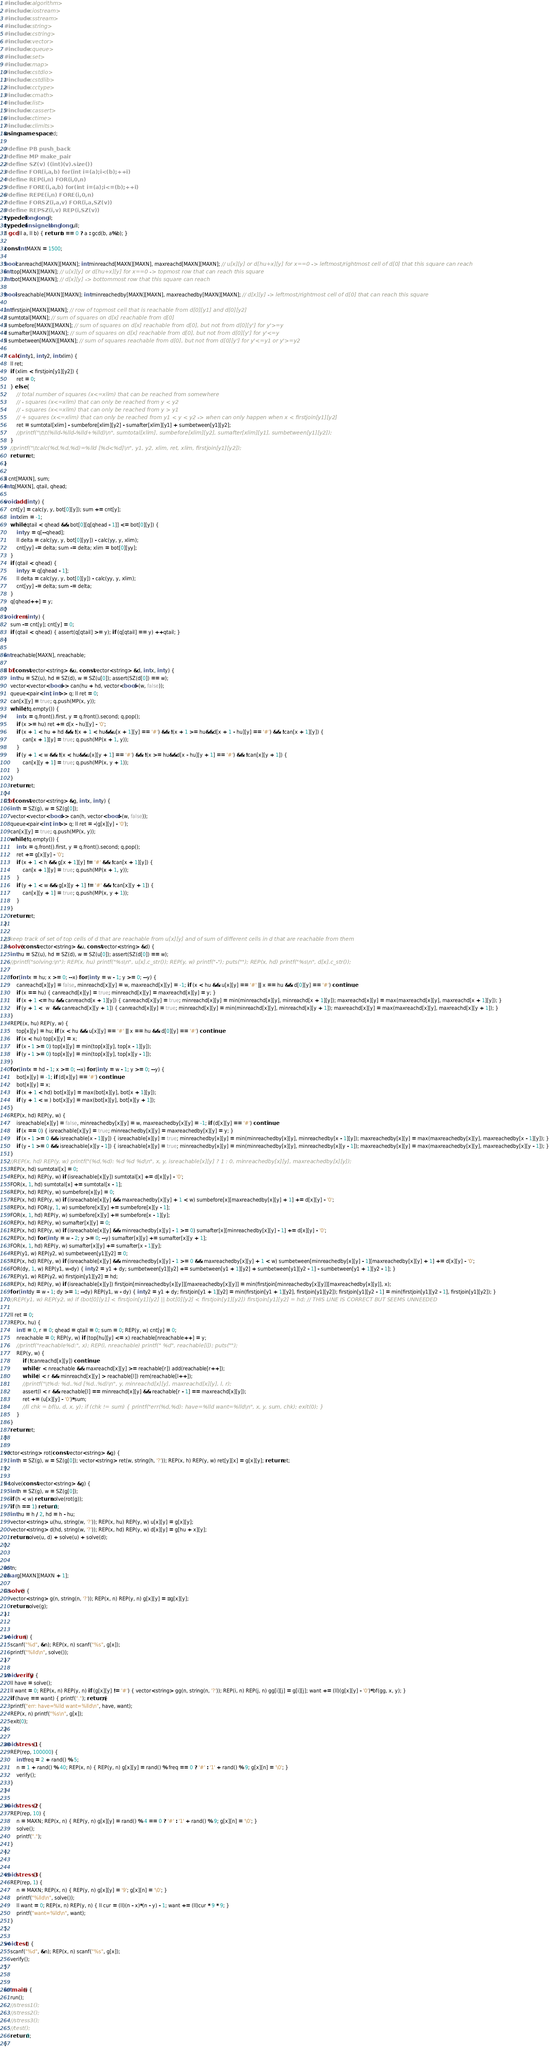Convert code to text. <code><loc_0><loc_0><loc_500><loc_500><_C++_>#include <algorithm>  
#include <iostream>  
#include <sstream>  
#include <string>  
#include <cstring>
#include <vector>  
#include <queue>  
#include <set>  
#include <map>  
#include <cstdio>  
#include <cstdlib>  
#include <cctype>  
#include <cmath>  
#include <list>  
#include <cassert>
#include <ctime>
#include <climits>
using namespace std;

#define PB push_back  
#define MP make_pair  
#define SZ(v) ((int)(v).size())  
#define FOR(i,a,b) for(int i=(a);i<(b);++i)  
#define REP(i,n) FOR(i,0,n)  
#define FORE(i,a,b) for(int i=(a);i<=(b);++i)  
#define REPE(i,n) FORE(i,0,n)  
#define FORSZ(i,a,v) FOR(i,a,SZ(v))  
#define REPSZ(i,v) REP(i,SZ(v))  
typedef long long ll;
typedef unsigned long long ull;
ll gcd(ll a, ll b) { return b == 0 ? a : gcd(b, a%b); }

const int MAXN = 1500;

bool canreachd[MAXN][MAXN]; int minreachd[MAXN][MAXN], maxreachd[MAXN][MAXN]; // u[x][y] or d[hu+x][y] for x==0 -> leftmost/rightmost cell of d[0] that this square can reach
int top[MAXN][MAXN]; // u[x][y] or d[hu+x][y] for x==0 -> topmost row that can reach this square
int bot[MAXN][MAXN]; // d[x][y] -> bottommost row that this square can reach

bool isreachable[MAXN][MAXN]; int minreachedby[MAXN][MAXN], maxreachedby[MAXN][MAXN]; // d[x][y] -> leftmost/rightmost cell of d[0] that can reach this square

int firstjoin[MAXN][MAXN]; // row of topmost cell that is reachable from d[0][y1] and d[0][y2]
ll sumtotal[MAXN]; // sum of squares on d[x] reachable from d[0]
ll sumbefore[MAXN][MAXN]; // sum of squares on d[x] reachable from d[0], but not from d[0][y'] for y'>=y
ll sumafter[MAXN][MAXN]; // sum of squares on d[x] reachable from d[0], but not from d[0][y'] for y'<=y
ll sumbetween[MAXN][MAXN]; // sum of squares reachable from d[0], but not from d[0][y'] for y'<=y1 or y'>=y2

ll calc(int y1, int y2, int xlim) {
	ll ret;
	if (xlim < firstjoin[y1][y2]) {
		ret = 0;
	} else {
		// total number of squares (x<=xlim) that can be reached from somewhere
		// - squares (x<=xlim) that can only be reached from y < y2
		// - squares (x<=xlim) that can only be reached from y > y1
		// + squares (x<=xlim) that can only be reached from y1 < y < y2 -> when can only happen when x < firstjoin[y1][y2]
		ret = sumtotal[xlim] - sumbefore[xlim][y2] - sumafter[xlim][y1] + sumbetween[y1][y2];
		//printf("\t\t(%lld-%lld-%lld+%lld)\n", sumtotal[xlim], sumbefore[xlim][y2], sumafter[xlim][y1], sumbetween[y1][y2]);
	}
	//printf("\tcalc(%d,%d,%d)=%lld [%d<%d]\n", y1, y2, xlim, ret, xlim, firstjoin[y1][y2]);
	return ret;
}

ll cnt[MAXN], sum;
int q[MAXN], qtail, qhead;

void add(int y) {
	cnt[y] = calc(y, y, bot[0][y]); sum += cnt[y];
	int xlim = -1;
	while (qtail < qhead && bot[0][q[qhead - 1]] <= bot[0][y]) {
		int yy = q[--qhead];
		ll delta = calc(yy, y, bot[0][yy]) - calc(yy, y, xlim);
		cnt[yy] -= delta; sum -= delta; xlim = bot[0][yy];
	}
	if (qtail < qhead) {
		int yy = q[qhead - 1];
		ll delta = calc(yy, y, bot[0][y]) - calc(yy, y, xlim);
		cnt[yy] -= delta; sum -= delta;
	}
	q[qhead++] = y;
}
void rem(int y) {
	sum -= cnt[y]; cnt[y] = 0;
	if (qtail < qhead) { assert(q[qtail] >= y); if (q[qtail] == y) ++qtail; }
}

int reachable[MAXN], nreachable;

ll bf(const vector<string> &u, const vector<string> &d, int x, int y) {
	int hu = SZ(u), hd = SZ(d), w = SZ(u[0]); assert(SZ(d[0]) == w);
	vector<vector<bool>> can(hu + hd, vector<bool>(w, false));
	queue<pair<int, int>> q; ll ret = 0;
	can[x][y] = true; q.push(MP(x, y));
	while (!q.empty()) {
		int x = q.front().first, y = q.front().second; q.pop();
		if (x >= hu) ret += d[x - hu][y] - '0';
		if (x + 1 < hu + hd && !(x + 1 < hu&&u[x + 1][y] == '#') && !(x + 1 >= hu&&d[x + 1 - hu][y] == '#') && !can[x + 1][y]) {
			can[x + 1][y] = true; q.push(MP(x + 1, y));
		}
		if (y + 1 < w && !(x < hu&&u[x][y + 1] == '#') && !(x >= hu&&d[x - hu][y + 1] == '#') && !can[x][y + 1]) {
			can[x][y + 1] = true; q.push(MP(x, y + 1));
		}
	}
	return ret;
}
ll bf(const vector<string> &g, int x, int y) {
	int h = SZ(g), w = SZ(g[0]);
	vector<vector<bool>> can(h, vector<bool>(w, false));
	queue<pair<int, int>> q; ll ret = -(g[x][y] - '0');
	can[x][y] = true; q.push(MP(x, y));
	while (!q.empty()) {
		int x = q.front().first, y = q.front().second; q.pop();
		ret += g[x][y] - '0';
		if (x + 1 < h && g[x + 1][y] != '#' && !can[x + 1][y]) {
			can[x + 1][y] = true; q.push(MP(x + 1, y));
		}
		if (y + 1 < w && g[x][y + 1] != '#' && !can[x][y + 1]) {
			can[x][y + 1] = true; q.push(MP(x, y + 1));
		}
	}
	return ret;
}

// keep track of set of top cells of d that are reachable from u[x][y] and of sum of different cells in d that are reachable from them
ll solve(const vector<string> &u, const vector<string> &d) {
	int hu = SZ(u), hd = SZ(d), w = SZ(u[0]); assert(SZ(d[0]) == w);
	//printf("solving:\n"); REP(x, hu) printf("%s\n", u[x].c_str()); REP(y, w) printf("-"); puts(""); REP(x, hd) printf("%s\n", d[x].c_str());

	for (int x = hu; x >= 0; --x) for (int y = w - 1; y >= 0; --y) {
		canreachd[x][y] = false, minreachd[x][y] = w, maxreachd[x][y] = -1; if (x < hu && u[x][y] == '#' || x == hu && d[0][y] == '#') continue;
		if (x == hu) { canreachd[x][y] = true; minreachd[x][y] = maxreachd[x][y] = y; }
		if (x + 1 <= hu && canreachd[x + 1][y]) { canreachd[x][y] = true; minreachd[x][y] = min(minreachd[x][y], minreachd[x + 1][y]); maxreachd[x][y] = max(maxreachd[x][y], maxreachd[x + 1][y]); }
		if (y + 1 <  w  && canreachd[x][y + 1]) { canreachd[x][y] = true; minreachd[x][y] = min(minreachd[x][y], minreachd[x][y + 1]); maxreachd[x][y] = max(maxreachd[x][y], maxreachd[x][y + 1]); }
	}
	REPE(x, hu) REP(y, w) {
		top[x][y] = hu; if (x < hu && u[x][y] == '#' || x == hu && d[0][y] == '#') continue;
		if (x < hu) top[x][y] = x;
		if (x - 1 >= 0) top[x][y] = min(top[x][y], top[x - 1][y]);
		if (y - 1 >= 0) top[x][y] = min(top[x][y], top[x][y - 1]);
	}
	for (int x = hd - 1; x >= 0; --x) for (int y = w - 1; y >= 0; --y) {
		bot[x][y] = -1; if (d[x][y] == '#') continue;
		bot[x][y] = x;
		if (x + 1 < hd) bot[x][y] = max(bot[x][y], bot[x + 1][y]);
		if (y + 1 < w ) bot[x][y] = max(bot[x][y], bot[x][y + 1]);
	}
	REP(x, hd) REP(y, w) {
		isreachable[x][y] = false, minreachedby[x][y] = w, maxreachedby[x][y] = -1; if (d[x][y] == '#') continue;
		if (x == 0) { isreachable[x][y] = true; minreachedby[x][y] = maxreachedby[x][y] = y; }
		if (x - 1 >= 0 && isreachable[x - 1][y]) { isreachable[x][y] = true; minreachedby[x][y] = min(minreachedby[x][y], minreachedby[x - 1][y]); maxreachedby[x][y] = max(maxreachedby[x][y], maxreachedby[x - 1][y]); }
		if (y - 1 >= 0 && isreachable[x][y - 1]) { isreachable[x][y] = true; minreachedby[x][y] = min(minreachedby[x][y], minreachedby[x][y - 1]); maxreachedby[x][y] = max(maxreachedby[x][y], maxreachedby[x][y - 1]); }
	}
	//REP(x, hd) REP(y, w) printf("(%d,%d): %d %d %d\n", x, y, isreachable[x][y] ? 1 : 0, minreachedby[x][y], maxreachedby[x][y]);
	REP(x, hd) sumtotal[x] = 0;
	REP(x, hd) REP(y, w) if (isreachable[x][y]) sumtotal[x] += d[x][y] - '0';
	FOR(x, 1, hd) sumtotal[x] += sumtotal[x - 1];
	REP(x, hd) REP(y, w) sumbefore[x][y] = 0;
	REP(x, hd) REP(y, w) if (isreachable[x][y] && maxreachedby[x][y] + 1 < w) sumbefore[x][maxreachedby[x][y] + 1] += d[x][y] - '0';
	REP(x, hd) FOR(y, 1, w) sumbefore[x][y] += sumbefore[x][y - 1];
	FOR(x, 1, hd) REP(y, w) sumbefore[x][y] += sumbefore[x - 1][y];
	REP(x, hd) REP(y, w) sumafter[x][y] = 0;
	REP(x, hd) REP(y, w) if (isreachable[x][y] && minreachedby[x][y] - 1 >= 0) sumafter[x][minreachedby[x][y] - 1] += d[x][y] - '0';
	REP(x, hd) for (int y = w - 2; y >= 0; --y) sumafter[x][y] += sumafter[x][y + 1];
	FOR(x, 1, hd) REP(y, w) sumafter[x][y] += sumafter[x - 1][y];
	REP(y1, w) REP(y2, w) sumbetween[y1][y2] = 0;
	REP(x, hd) REP(y, w) if (isreachable[x][y] && minreachedby[x][y] - 1 >= 0 && maxreachedby[x][y] + 1 < w) sumbetween[minreachedby[x][y] - 1][maxreachedby[x][y] + 1] += d[x][y] - '0';
	FOR(dy, 1, w) REP(y1, w-dy) { int y2 = y1 + dy; sumbetween[y1][y2] += sumbetween[y1 + 1][y2] + sumbetween[y1][y2 - 1] - sumbetween[y1 + 1][y2 - 1]; }
	REP(y1, w) REP(y2, w) firstjoin[y1][y2] = hd;
	REP(x, hd) REP(y, w) if (isreachable[x][y]) firstjoin[minreachedby[x][y]][maxreachedby[x][y]] = min(firstjoin[minreachedby[x][y]][maxreachedby[x][y]], x);
	for (int dy = w - 1; dy >= 1; --dy) REP(y1, w - dy) { int y2 = y1 + dy; firstjoin[y1 + 1][y2] = min(firstjoin[y1 + 1][y2], firstjoin[y1][y2]); firstjoin[y1][y2 - 1] = min(firstjoin[y1][y2 - 1], firstjoin[y1][y2]); }
	//REP(y1, w) REP(y2, w) if (bot[0][y1] < firstjoin[y1][y2] || bot[0][y2] < firstjoin[y1][y2]) firstjoin[y1][y2] = hd; // THIS LINE IS CORRECT BUT SEEMS UNNEEDED

	ll ret = 0;
	REP(x, hu) {
		int l = 0, r = 0; qhead = qtail = 0; sum = 0; REP(y, w) cnt[y] = 0;
		nreachable = 0; REP(y, w) if (top[hu][y] <= x) reachable[nreachable++] = y;
		//printf("reachable%d:", x); REP(i, nreachable) printf(" %d", reachable[i]); puts("");
		REP(y, w) {
			if (!canreachd[x][y]) continue;
			while (r < nreachable && maxreachd[x][y] >= reachable[r]) add(reachable[r++]);
			while (l < r && minreachd[x][y] > reachable[l]) rem(reachable[l++]);
			//printf("\t%d: %d..%d [%d..%d)\n", y, minreachd[x][y], maxreachd[x][y], l, r);
			assert(l < r && reachable[l] == minreachd[x][y] && reachable[r - 1] == maxreachd[x][y]);
			ret += (u[x][y] - '0')*sum;
			//ll chk = bf(u, d, x, y); if (chk != sum) { printf("err(%d,%d): have=%lld want=%lld\n", x, y, sum, chk); exit(0); }
		}
	}
	return ret;
}

vector<string> rot(const vector<string> &g) {
	int h = SZ(g), w = SZ(g[0]); vector<string> ret(w, string(h, '?')); REP(x, h) REP(y, w) ret[y][x] = g[x][y]; return ret;
}

ll solve(const vector<string> &g) {
	int h = SZ(g), w = SZ(g[0]);
	if (h < w) return solve(rot(g));
	if (h == 1) return 0;
	int hu = h / 2, hd = h - hu;
	vector<string> u(hu, string(w, '?')); REP(x, hu) REP(y, w) u[x][y] = g[x][y];
	vector<string> d(hd, string(w, '?')); REP(x, hd) REP(y, w) d[x][y] = g[hu + x][y];
	return solve(u, d) + solve(u) + solve(d);
}


int n;
char g[MAXN][MAXN + 1];

ll solve() {
	vector<string> g(n, string(n, '?')); REP(x, n) REP(y, n) g[x][y] = ::g[x][y];
	return solve(g); 
}


void run() {
	scanf("%d", &n); REP(x, n) scanf("%s", g[x]);
	printf("%lld\n", solve());
}

void verify() {
	ll have = solve();
	ll want = 0; REP(x, n) REP(y, n) if (g[x][y] != '#') { vector<string> gg(n, string(n, '?')); REP(i, n) REP(j, n) gg[i][j] = g[i][j]; want += (ll)(g[x][y] - '0')*bf(gg, x, y); }
	if (have == want) { printf("."); return; }
	printf("err: have=%lld want=%lld\n", have, want);
	REP(x, n) printf("%s\n", g[x]);
	exit(0);
}

void stress1() {
	REP(rep, 100000) {
		int freq = 2 + rand() % 5;
		n = 1 + rand() % 40; REP(x, n) { REP(y, n) g[x][y] = rand() % freq == 0 ? '#' : '1' + rand() % 9; g[x][n] = '\0'; }
		verify();
	}
}

void stress2() {
	REP(rep, 10) {
		n = MAXN; REP(x, n) { REP(y, n) g[x][y] = rand() % 4 == 0 ? '#' : '1' + rand() % 9; g[x][n] = '\0'; }
		solve();
		printf(".");
	}
}


void stress3() {
	REP(rep, 1) {
		n = MAXN; REP(x, n) { REP(y, n) g[x][y] = '9'; g[x][n] = '\0'; }
		printf("%lld\n", solve());
		ll want = 0; REP(x, n) REP(y, n) { ll cur = (ll)(n - x)*(n - y) - 1; want += (ll)cur * 9 * 9; }
		printf("want=%lld\n", want);
	}
}

void test() {
	scanf("%d", &n); REP(x, n) scanf("%s", g[x]);
	verify();
}


int main() {
	run();
	//stress1();
	//stress2();
	//stress3();
	//test();
	return 0;
}
</code> 